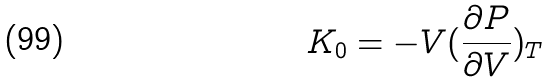<formula> <loc_0><loc_0><loc_500><loc_500>K _ { 0 } = - V ( \frac { \partial P } { \partial V } ) _ { T }</formula> 